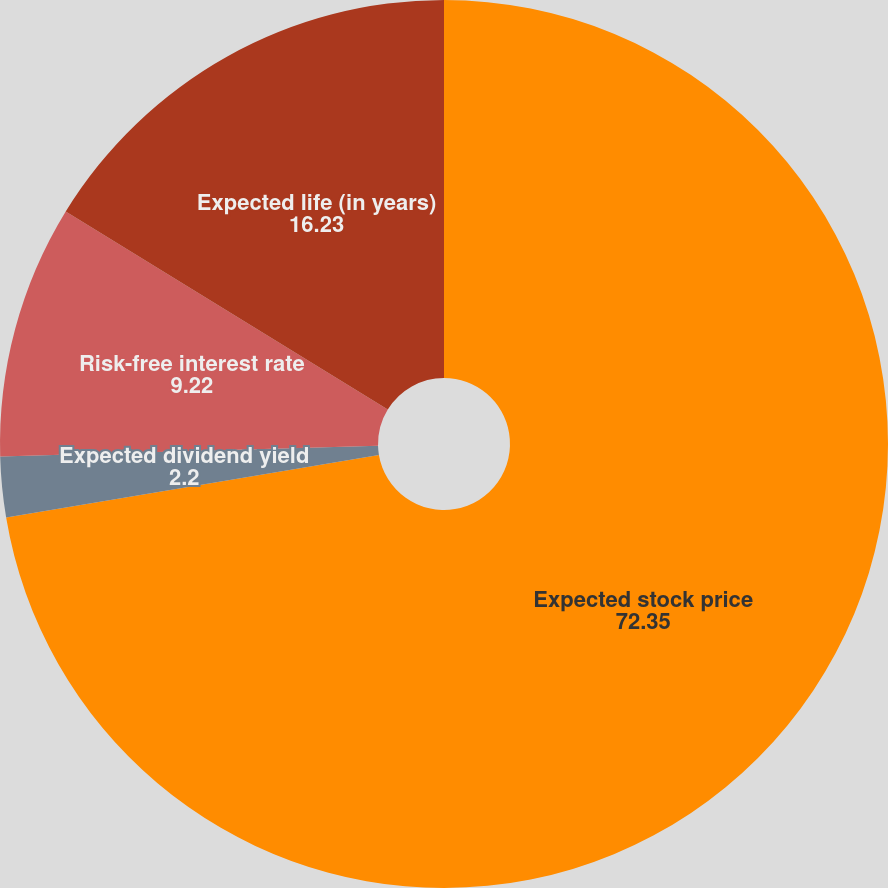Convert chart. <chart><loc_0><loc_0><loc_500><loc_500><pie_chart><fcel>Expected stock price<fcel>Expected dividend yield<fcel>Risk-free interest rate<fcel>Expected life (in years)<nl><fcel>72.35%<fcel>2.2%<fcel>9.22%<fcel>16.23%<nl></chart> 